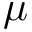Convert formula to latex. <formula><loc_0><loc_0><loc_500><loc_500>\mu</formula> 